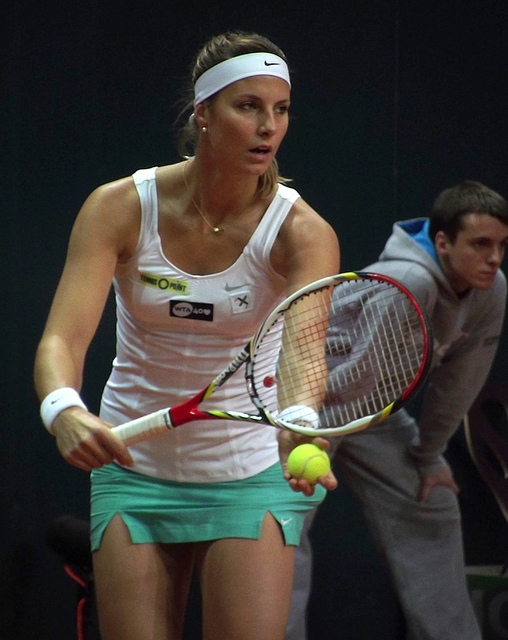<image>What brand is she sponsored by? I don't know what brand she is sponsored by. It could be by 'nike', 'wta' or 'napa'. What color is her sports bra? I am not sure. It could be white, but her sports bra cannot be seen. What city is listed on her shirt? I don't know what city is listed on her shirt. It is not visible. What brand is she sponsored by? I don't know what brand she is sponsored by. It can be Nike, WTA, Napa, or Tennis Point WTA 40 Nike. What color is her sports bra? I am not sure the color of her sports bra. It can be white. What city is listed on her shirt? There is no city listed on her shirt. However, it can be seen 'London' or 'New York'. 